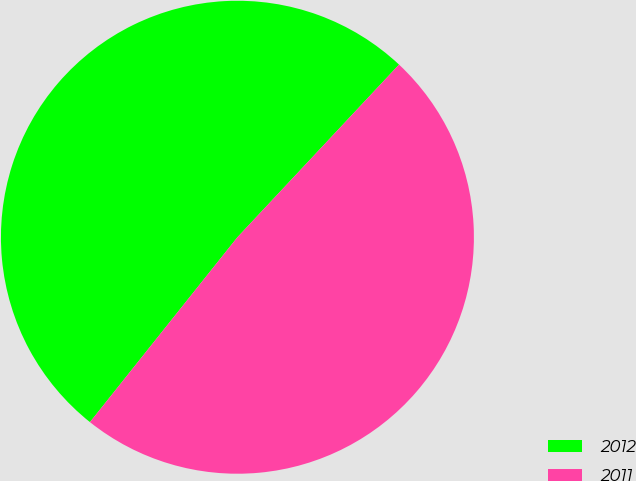<chart> <loc_0><loc_0><loc_500><loc_500><pie_chart><fcel>2012<fcel>2011<nl><fcel>51.26%<fcel>48.74%<nl></chart> 